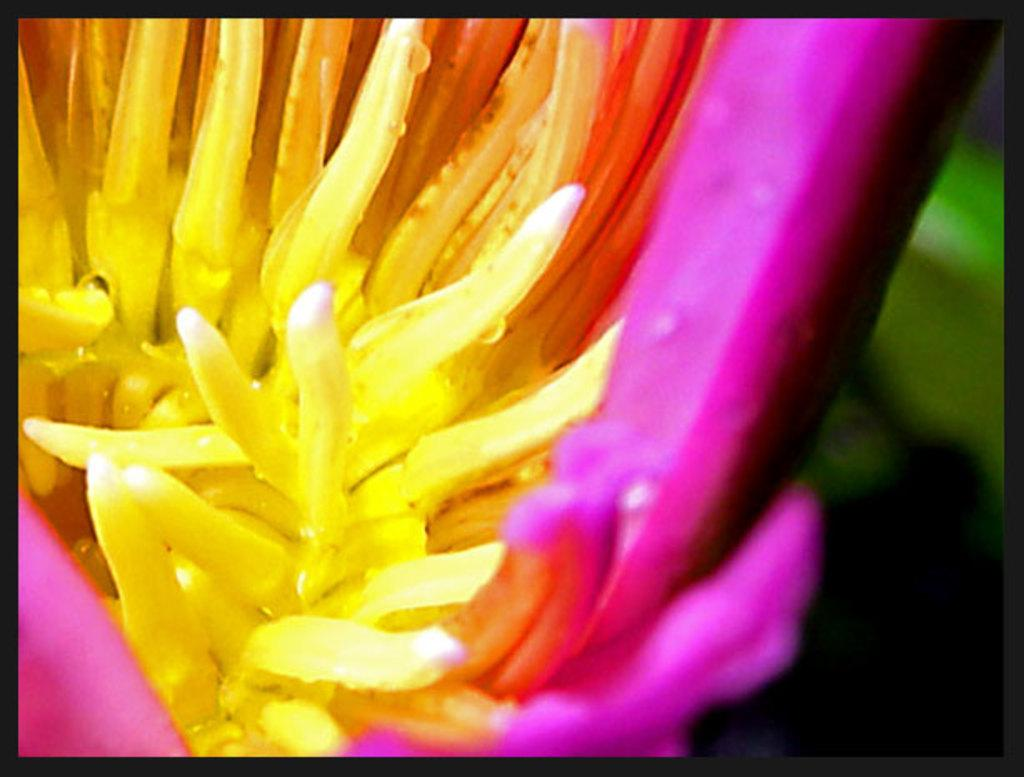What is the main subject of the image? There is a flower in the image. Can you describe the colors of the flower? The flower has pink and yellow colors. What colors can be seen in the background of the image? The background of the image is green and black. How many frogs are sitting on the flower in the image? There are no frogs present in the image; it only features a flower with pink and yellow colors against a green and black background. 